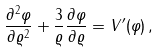<formula> <loc_0><loc_0><loc_500><loc_500>\frac { \partial ^ { 2 } \varphi } { \partial \varrho ^ { 2 } } + \frac { 3 } { \varrho } \frac { \partial \varphi } { \partial \varrho } = V ^ { \prime } ( \varphi ) \, ,</formula> 